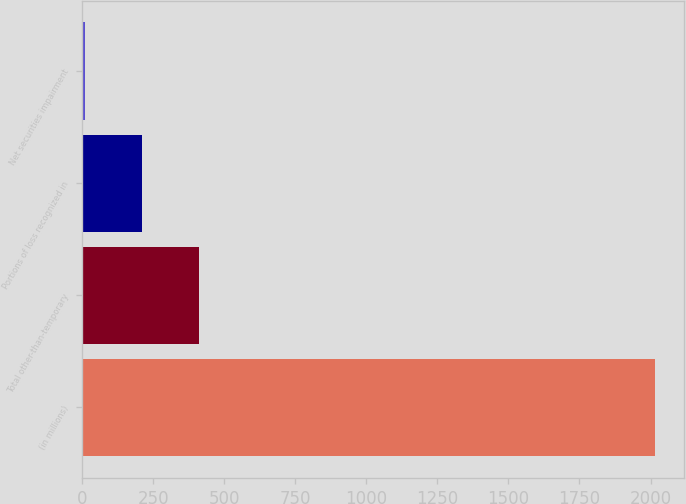Convert chart. <chart><loc_0><loc_0><loc_500><loc_500><bar_chart><fcel>(in millions)<fcel>Total other-than-temporary<fcel>Portions of loss recognized in<fcel>Net securities impairment<nl><fcel>2016<fcel>412.8<fcel>212.4<fcel>12<nl></chart> 